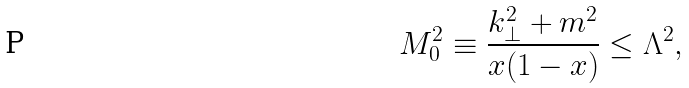Convert formula to latex. <formula><loc_0><loc_0><loc_500><loc_500>M _ { 0 } ^ { 2 } \equiv \frac { k _ { \perp } ^ { 2 } + m ^ { 2 } } { x ( 1 - x ) } \leq \Lambda ^ { 2 } ,</formula> 